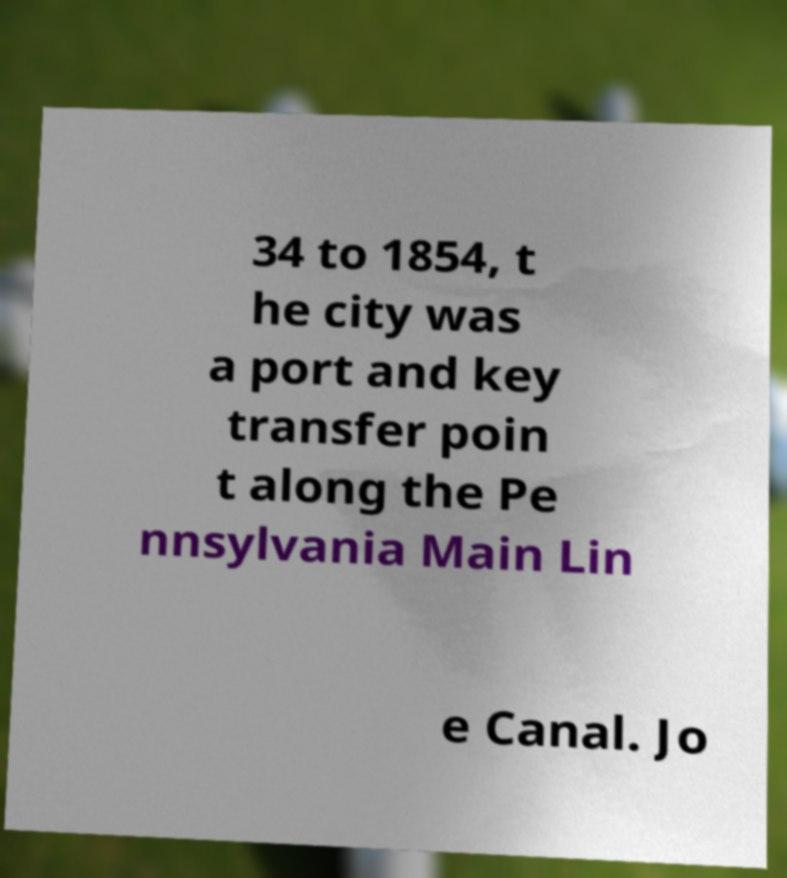Please identify and transcribe the text found in this image. 34 to 1854, t he city was a port and key transfer poin t along the Pe nnsylvania Main Lin e Canal. Jo 